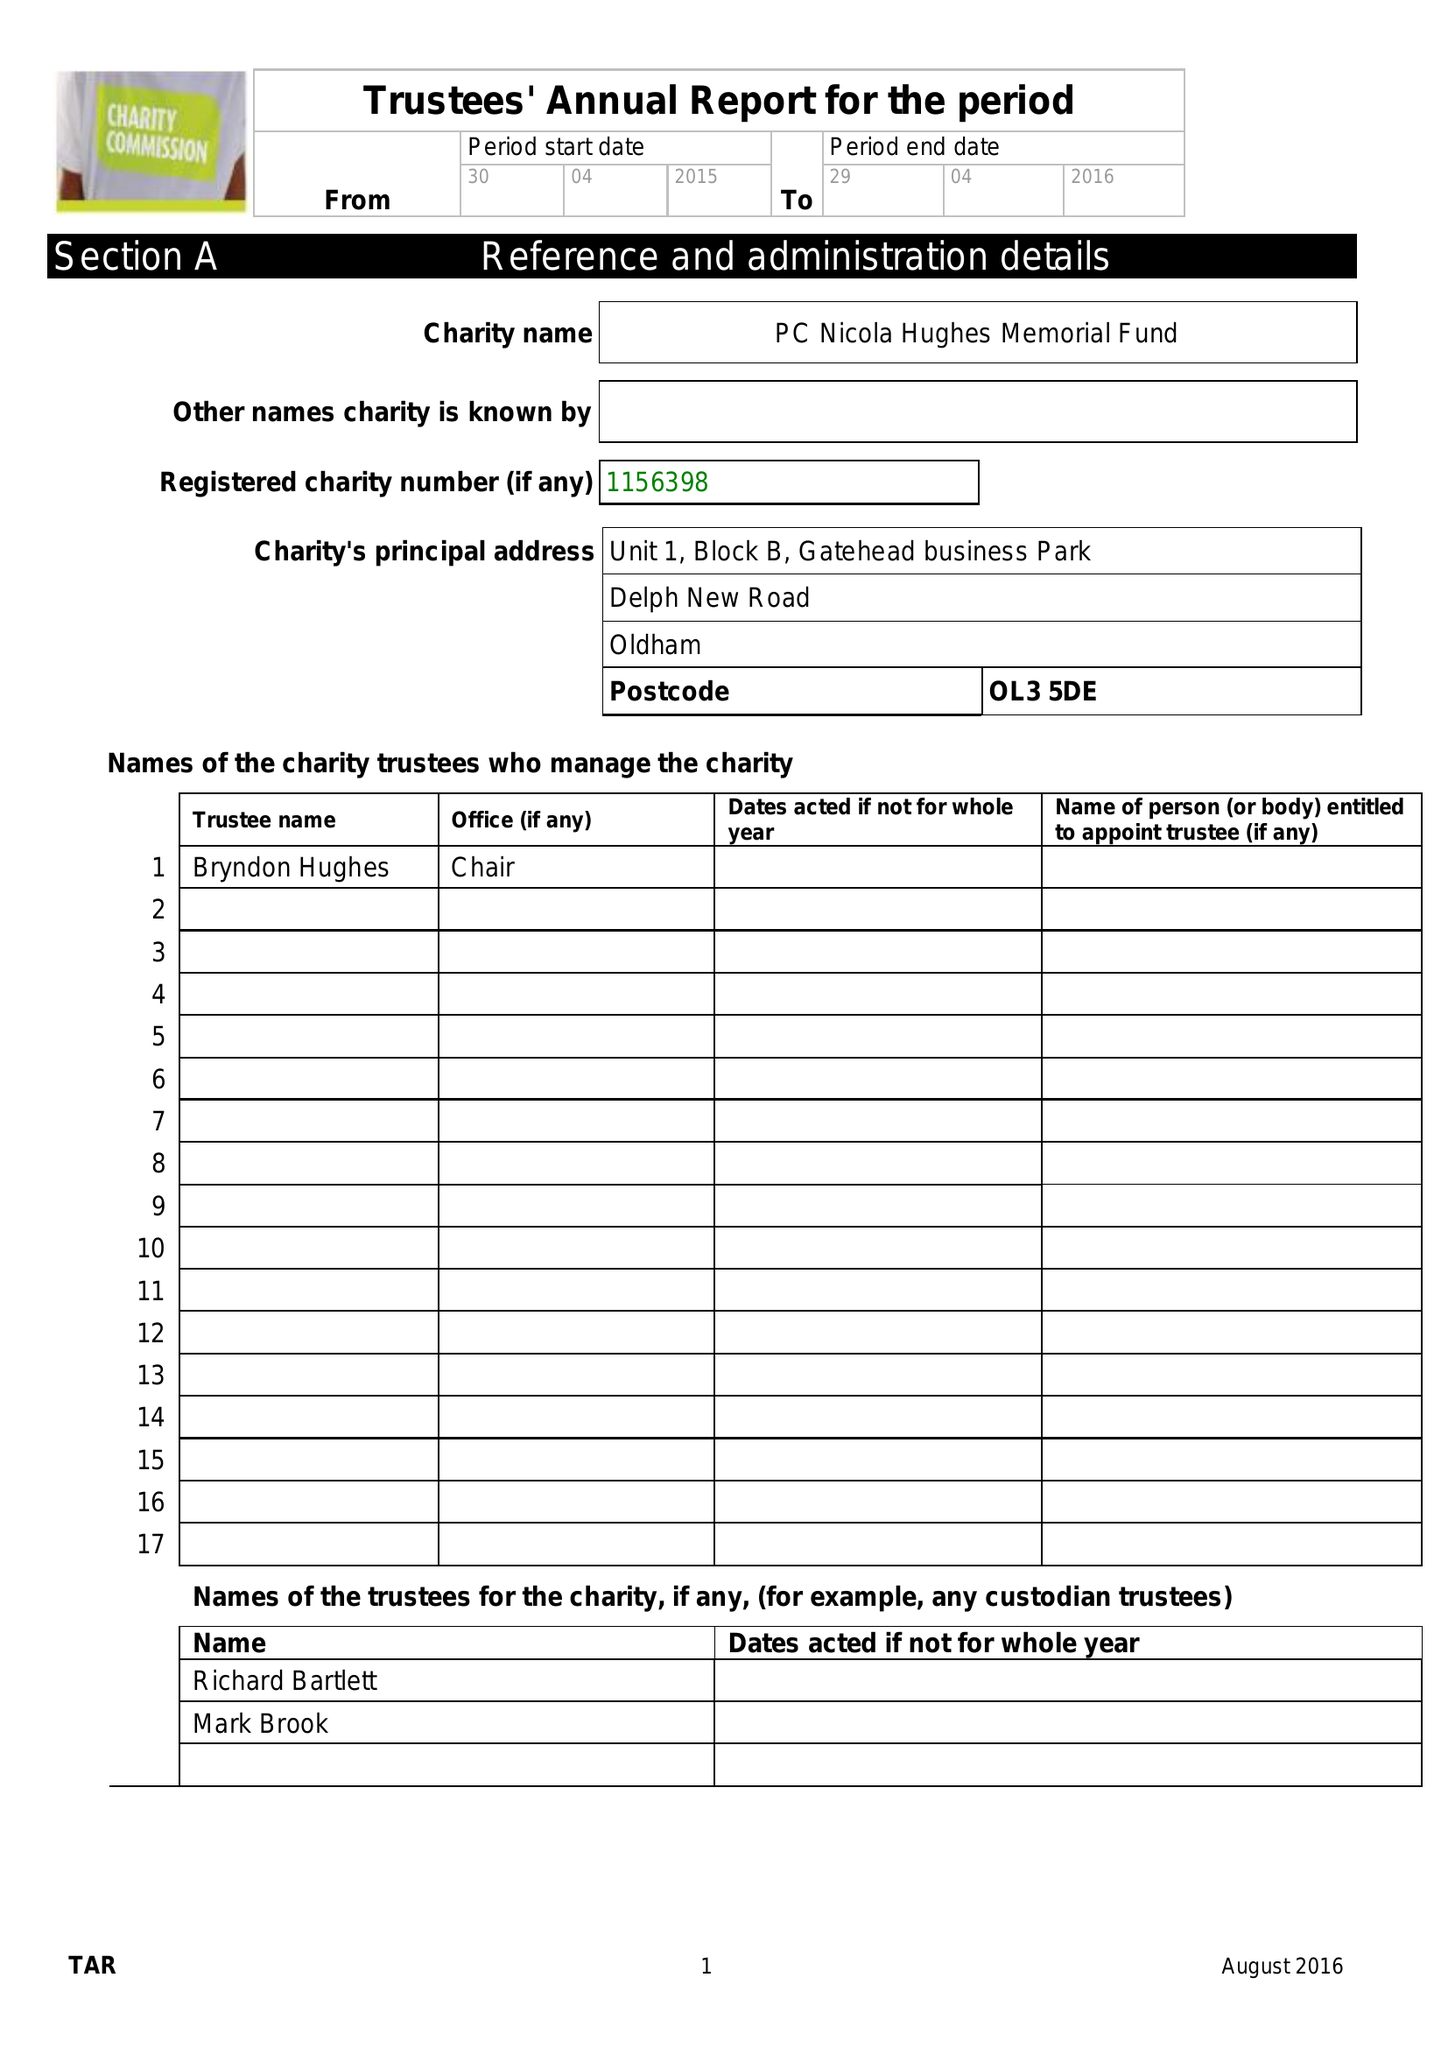What is the value for the report_date?
Answer the question using a single word or phrase. 2016-04-29 